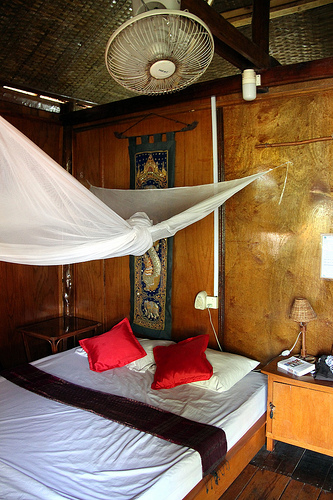<image>
Can you confirm if the book is on the bed? No. The book is not positioned on the bed. They may be near each other, but the book is not supported by or resting on top of the bed. Where is the lamp in relation to the table? Is it next to the table? No. The lamp is not positioned next to the table. They are located in different areas of the scene. 